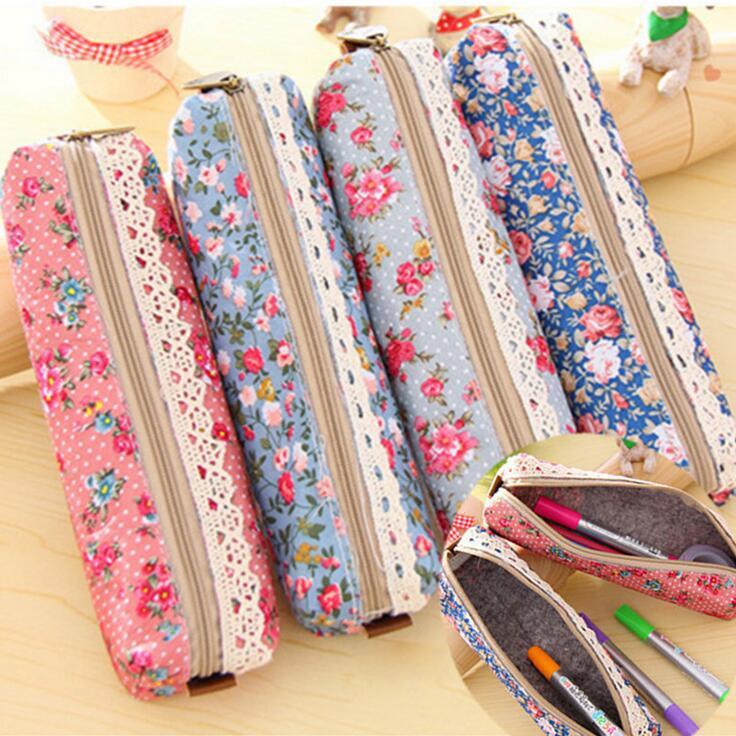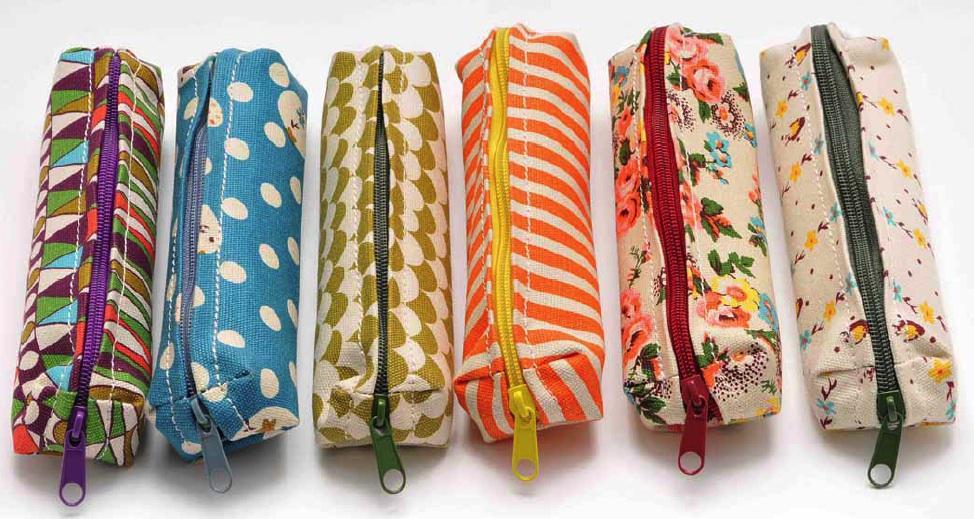The first image is the image on the left, the second image is the image on the right. Analyze the images presented: Is the assertion "The left image shows exactly one pencil case." valid? Answer yes or no. No. 